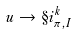Convert formula to latex. <formula><loc_0><loc_0><loc_500><loc_500>u \to \S i ^ { k } _ { \pi , I }</formula> 